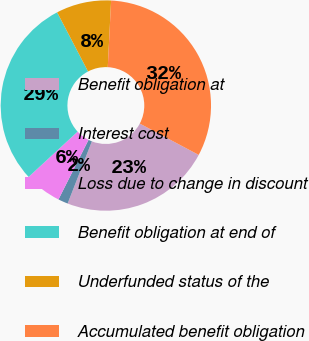Convert chart to OTSL. <chart><loc_0><loc_0><loc_500><loc_500><pie_chart><fcel>Benefit obligation at<fcel>Interest cost<fcel>Loss due to change in discount<fcel>Benefit obligation at end of<fcel>Underfunded status of the<fcel>Accumulated benefit obligation<nl><fcel>23.14%<fcel>1.52%<fcel>5.69%<fcel>29.21%<fcel>8.46%<fcel>31.98%<nl></chart> 